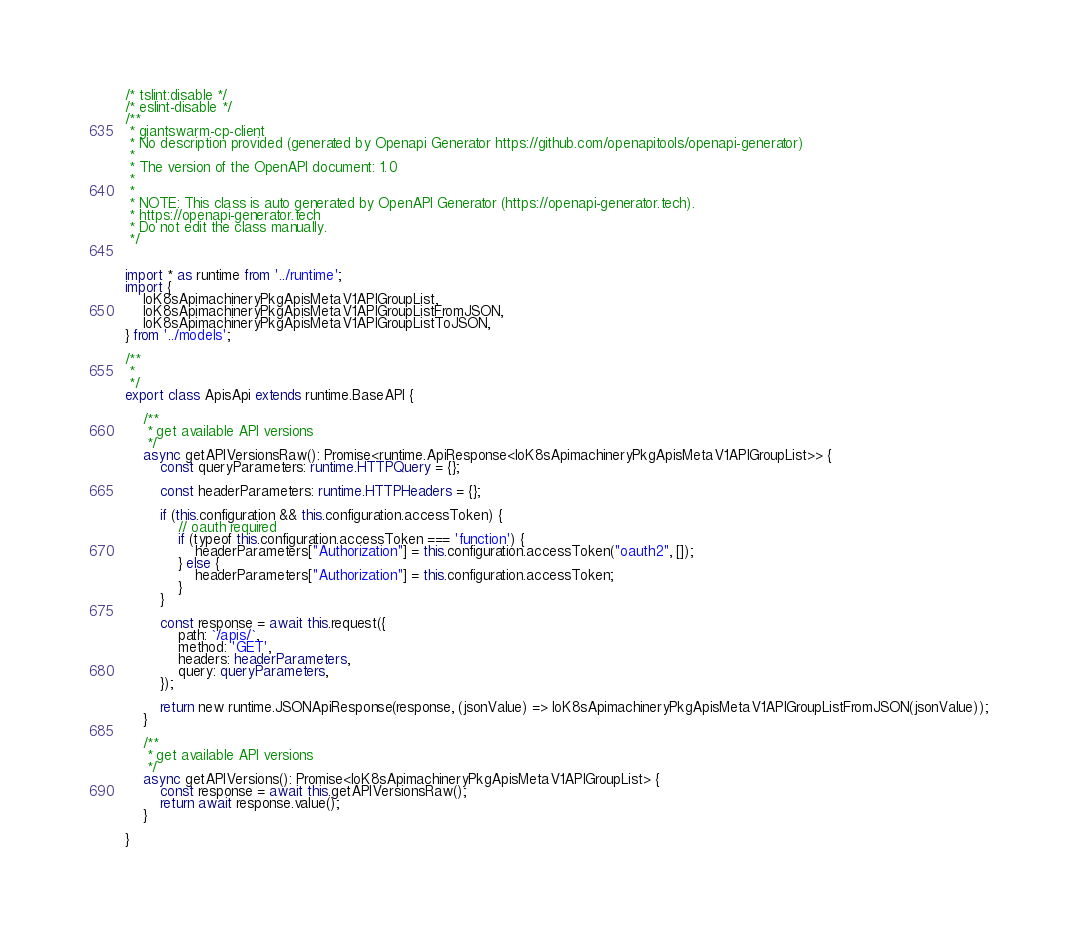<code> <loc_0><loc_0><loc_500><loc_500><_TypeScript_>/* tslint:disable */
/* eslint-disable */
/**
 * giantswarm-cp-client
 * No description provided (generated by Openapi Generator https://github.com/openapitools/openapi-generator)
 *
 * The version of the OpenAPI document: 1.0
 * 
 *
 * NOTE: This class is auto generated by OpenAPI Generator (https://openapi-generator.tech).
 * https://openapi-generator.tech
 * Do not edit the class manually.
 */


import * as runtime from '../runtime';
import {
    IoK8sApimachineryPkgApisMetaV1APIGroupList,
    IoK8sApimachineryPkgApisMetaV1APIGroupListFromJSON,
    IoK8sApimachineryPkgApisMetaV1APIGroupListToJSON,
} from '../models';

/**
 * 
 */
export class ApisApi extends runtime.BaseAPI {

    /**
     * get available API versions
     */
    async getAPIVersionsRaw(): Promise<runtime.ApiResponse<IoK8sApimachineryPkgApisMetaV1APIGroupList>> {
        const queryParameters: runtime.HTTPQuery = {};

        const headerParameters: runtime.HTTPHeaders = {};

        if (this.configuration && this.configuration.accessToken) {
            // oauth required
            if (typeof this.configuration.accessToken === 'function') {
                headerParameters["Authorization"] = this.configuration.accessToken("oauth2", []);
            } else {
                headerParameters["Authorization"] = this.configuration.accessToken;
            }
        }

        const response = await this.request({
            path: `/apis/`,
            method: 'GET',
            headers: headerParameters,
            query: queryParameters,
        });

        return new runtime.JSONApiResponse(response, (jsonValue) => IoK8sApimachineryPkgApisMetaV1APIGroupListFromJSON(jsonValue));
    }

    /**
     * get available API versions
     */
    async getAPIVersions(): Promise<IoK8sApimachineryPkgApisMetaV1APIGroupList> {
        const response = await this.getAPIVersionsRaw();
        return await response.value();
    }

}
</code> 